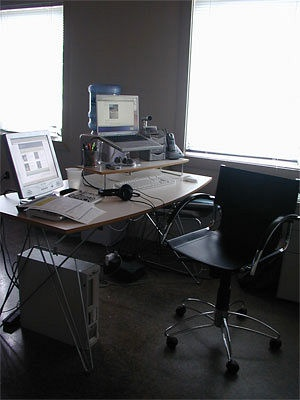Describe the objects in this image and their specific colors. I can see chair in gray and black tones, laptop in gray, lavender, and darkgray tones, laptop in gray, darkgray, and black tones, keyboard in gray and darkgray tones, and keyboard in gray and black tones in this image. 